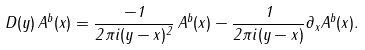Convert formula to latex. <formula><loc_0><loc_0><loc_500><loc_500>D ( y ) \, A ^ { b } ( x ) = { \frac { - 1 } { 2 \pi i ( y - x ) ^ { 2 } } } \, A ^ { b } ( x ) - { \frac { 1 } { 2 \pi i ( y - x ) } } \partial _ { x } A ^ { b } ( x ) .</formula> 